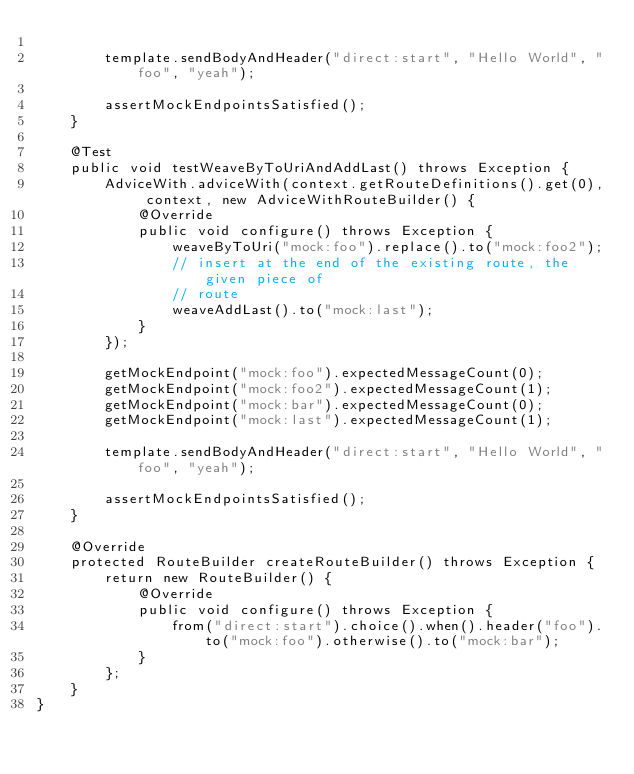Convert code to text. <code><loc_0><loc_0><loc_500><loc_500><_Java_>
        template.sendBodyAndHeader("direct:start", "Hello World", "foo", "yeah");

        assertMockEndpointsSatisfied();
    }

    @Test
    public void testWeaveByToUriAndAddLast() throws Exception {
        AdviceWith.adviceWith(context.getRouteDefinitions().get(0), context, new AdviceWithRouteBuilder() {
            @Override
            public void configure() throws Exception {
                weaveByToUri("mock:foo").replace().to("mock:foo2");
                // insert at the end of the existing route, the given piece of
                // route
                weaveAddLast().to("mock:last");
            }
        });

        getMockEndpoint("mock:foo").expectedMessageCount(0);
        getMockEndpoint("mock:foo2").expectedMessageCount(1);
        getMockEndpoint("mock:bar").expectedMessageCount(0);
        getMockEndpoint("mock:last").expectedMessageCount(1);

        template.sendBodyAndHeader("direct:start", "Hello World", "foo", "yeah");

        assertMockEndpointsSatisfied();
    }

    @Override
    protected RouteBuilder createRouteBuilder() throws Exception {
        return new RouteBuilder() {
            @Override
            public void configure() throws Exception {
                from("direct:start").choice().when().header("foo").to("mock:foo").otherwise().to("mock:bar");
            }
        };
    }
}
</code> 